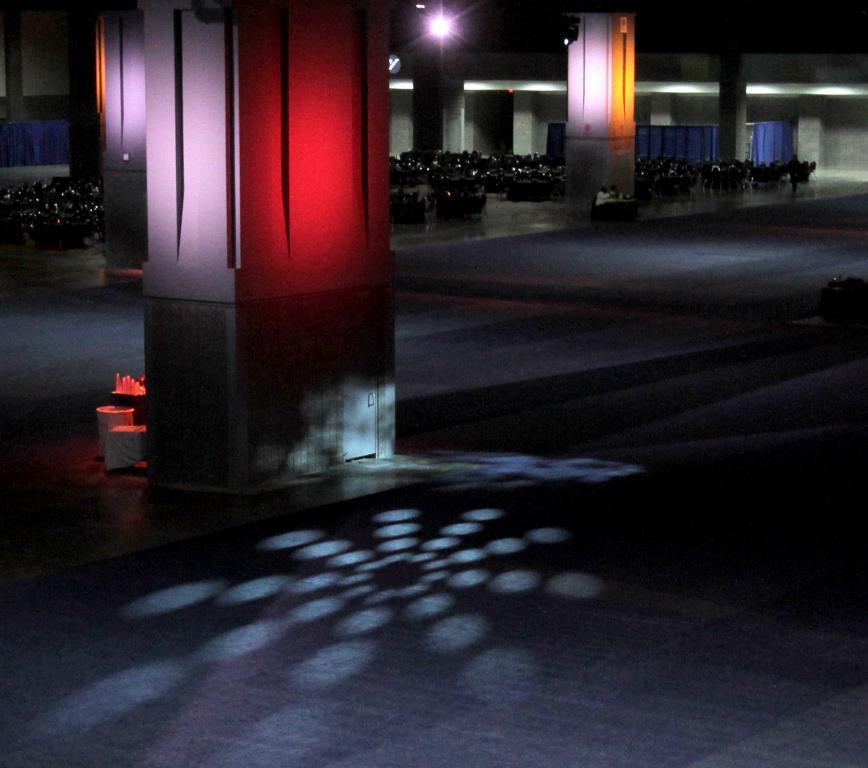Could you give a brief overview of what you see in this image? In this picture we can see many bikes which are parked near to the pillars and wall. On the top there is a light. On the left we can see tissue papers, cotton box and other objects near to this pillar. 